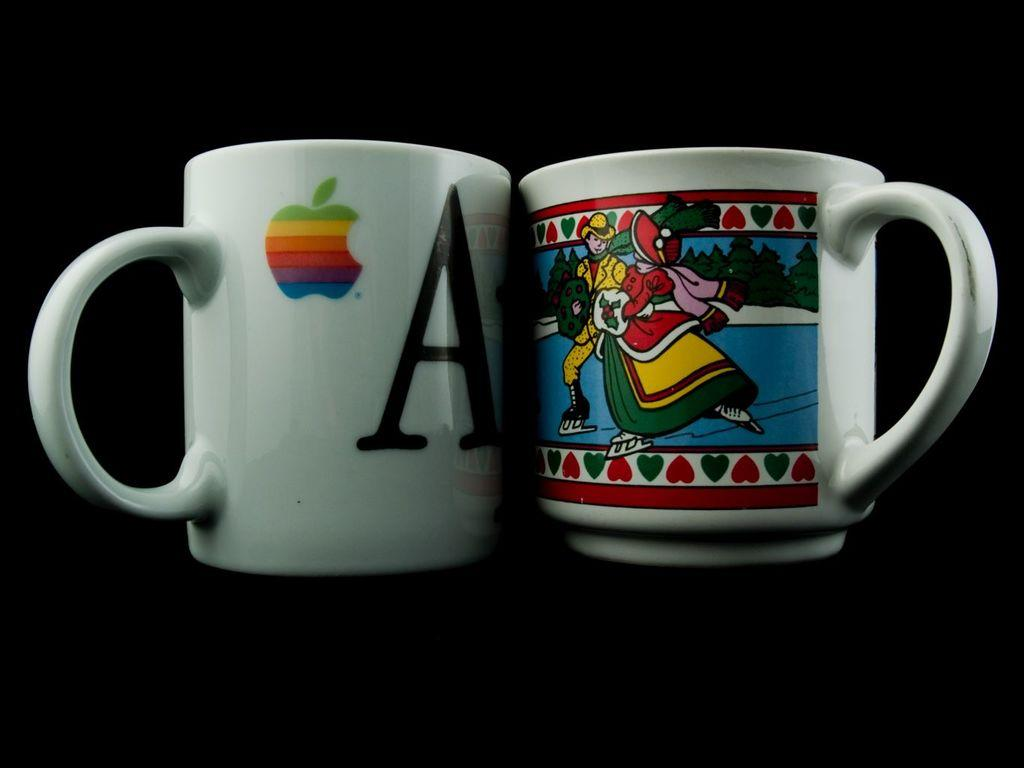Provide a one-sentence caption for the provided image. Two coffee mugs, one of which has a large letter "A" on it. 